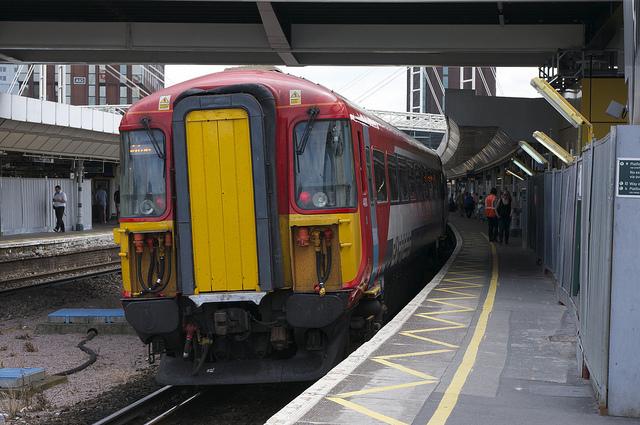Can we see the conductor of the train?
Write a very short answer. No. Is the roof higher than the top of the train?
Write a very short answer. Yes. How many circles are on the front of the train?
Keep it brief. 4. Which cartoon character's shirt does the zigzagging yellow line resemble?
Be succinct. Charlie brown. 